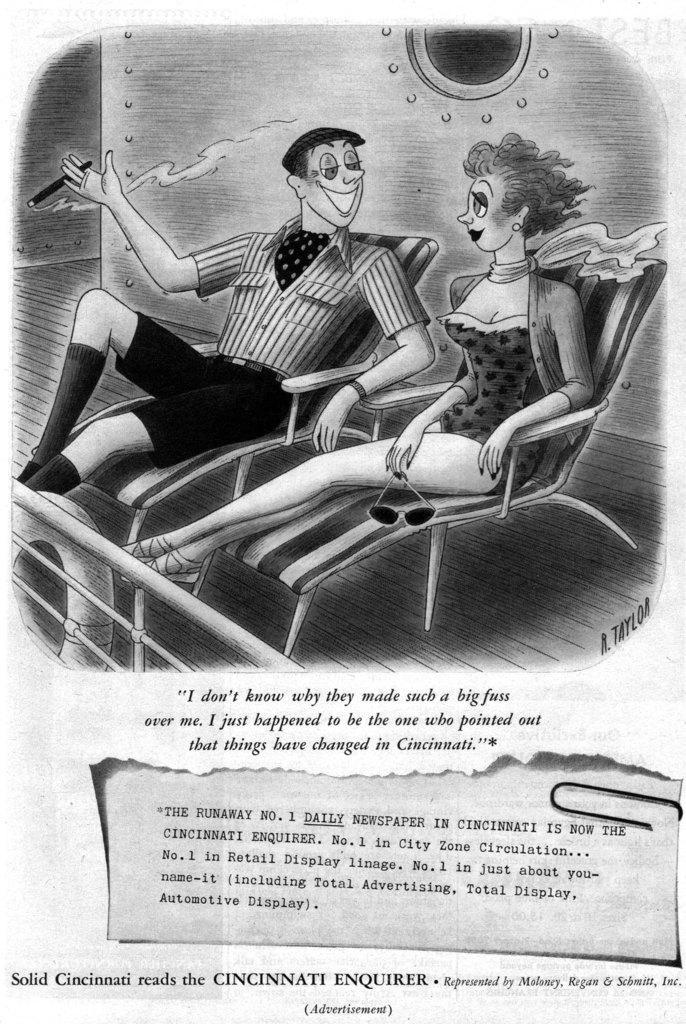Describe this image in one or two sentences. The picture is a newspaper column. The picture there is a cartoon of two people sitting in beach chairs. At the bottom there is text. 